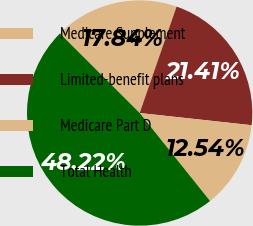<chart> <loc_0><loc_0><loc_500><loc_500><pie_chart><fcel>Medicare Supplement<fcel>Limited-benefit plans<fcel>Medicare Part D<fcel>Total Health<nl><fcel>17.84%<fcel>21.41%<fcel>12.54%<fcel>48.22%<nl></chart> 